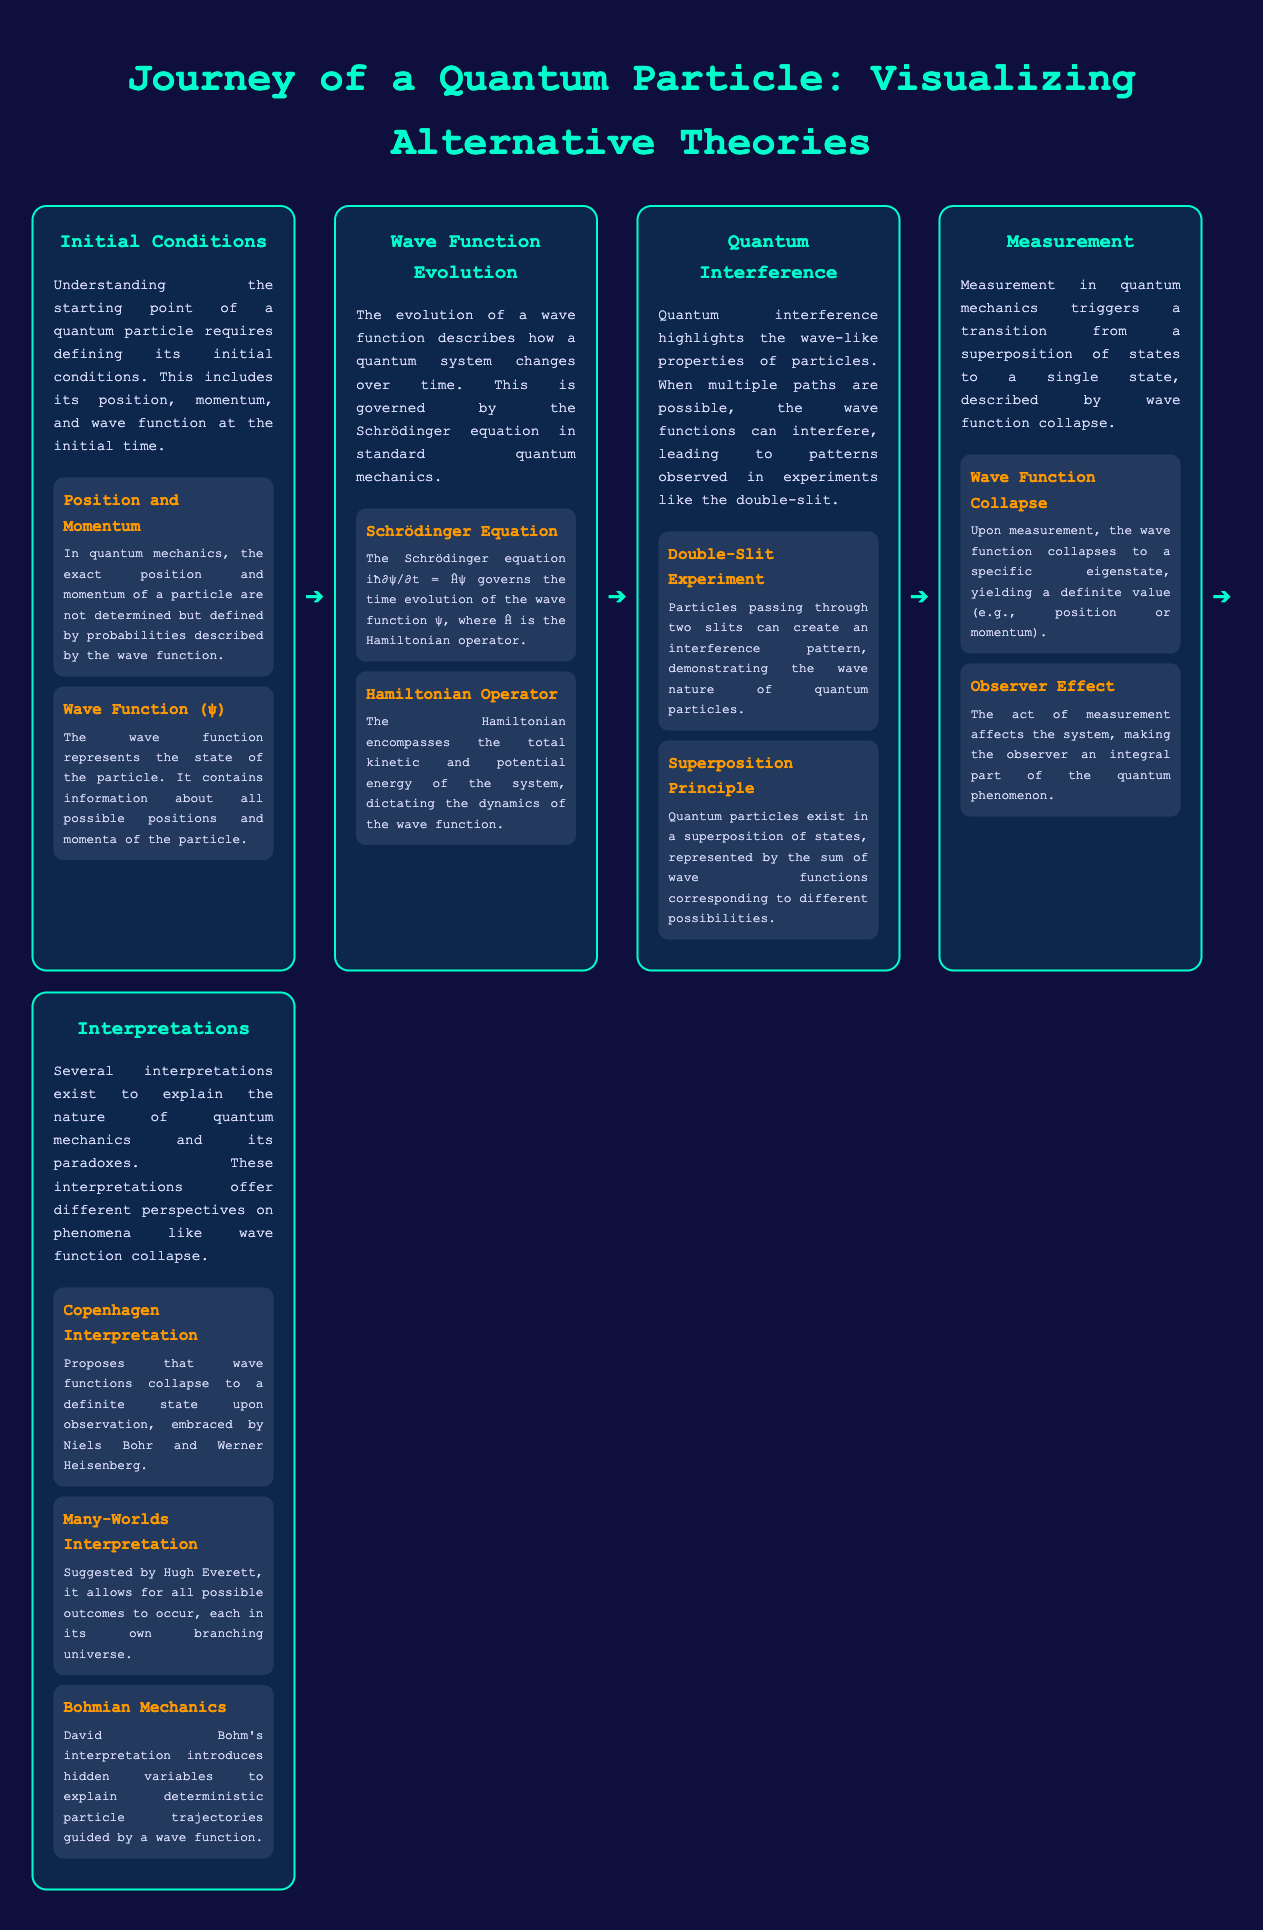What are initial conditions in quantum mechanics? Initial conditions include the position, momentum, and wave function of a quantum particle at the initial time.
Answer: Position, momentum, wave function What is the Schrödinger equation? The Schrödinger equation governs the time evolution of the wave function.
Answer: iħ∂ψ/∂t = Ĥψ What experiment demonstrates quantum interference? The double-slit experiment shows how particles exhibit wave-like properties through interference.
Answer: Double-slit experiment What happens during wave function collapse? The wave function collapses to a specific eigenstate, yielding a definite value upon measurement.
Answer: Collapses to a specific eigenstate Who proposed the Many-Worlds interpretation? Hugh Everett suggested the Many-Worlds interpretation, where all outcomes occur in branching universes.
Answer: Hugh Everett What does the Hamiltonian operator describe? The Hamiltonian encompasses the total kinetic and potential energy of the quantum system.
Answer: Total kinetic and potential energy What principle do quantum particles follow when in superposition? Quantum particles exist in a superposition of states, represented by the sum of wave functions.
Answer: Superposition principle What effect does measurement have on a quantum system? Measurement triggers a transition from a superposition of states to a single state.
Answer: Transition to a single state What interpretation embraces wave function collapse upon observation? The Copenhagen Interpretation suggests wave functions collapse to a definite state upon observation.
Answer: Copenhagen Interpretation 